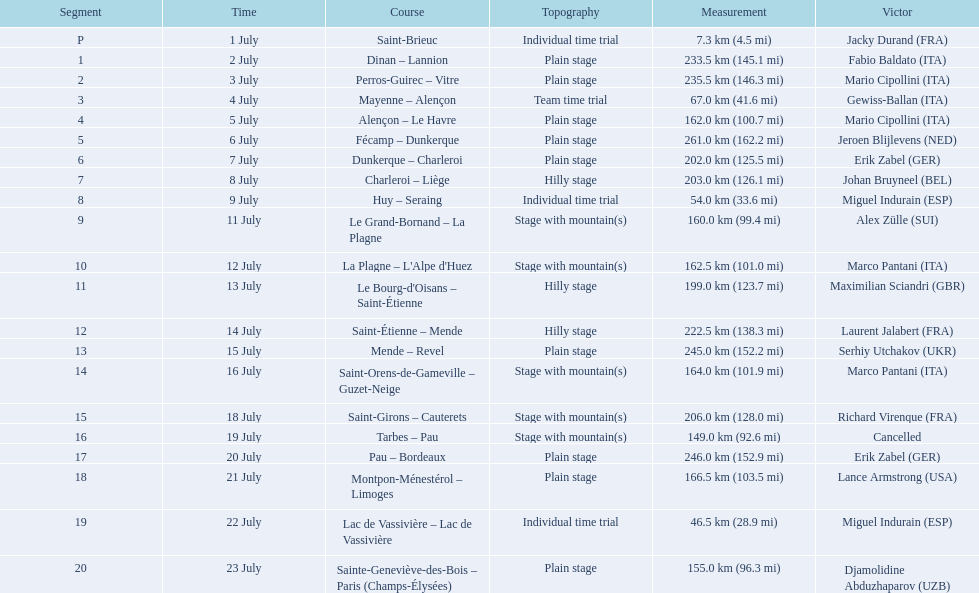What were the lengths of all the stages of the 1995 tour de france? 7.3 km (4.5 mi), 233.5 km (145.1 mi), 235.5 km (146.3 mi), 67.0 km (41.6 mi), 162.0 km (100.7 mi), 261.0 km (162.2 mi), 202.0 km (125.5 mi), 203.0 km (126.1 mi), 54.0 km (33.6 mi), 160.0 km (99.4 mi), 162.5 km (101.0 mi), 199.0 km (123.7 mi), 222.5 km (138.3 mi), 245.0 km (152.2 mi), 164.0 km (101.9 mi), 206.0 km (128.0 mi), 149.0 km (92.6 mi), 246.0 km (152.9 mi), 166.5 km (103.5 mi), 46.5 km (28.9 mi), 155.0 km (96.3 mi). Of those, which one occurred on july 8th? 203.0 km (126.1 mi). 